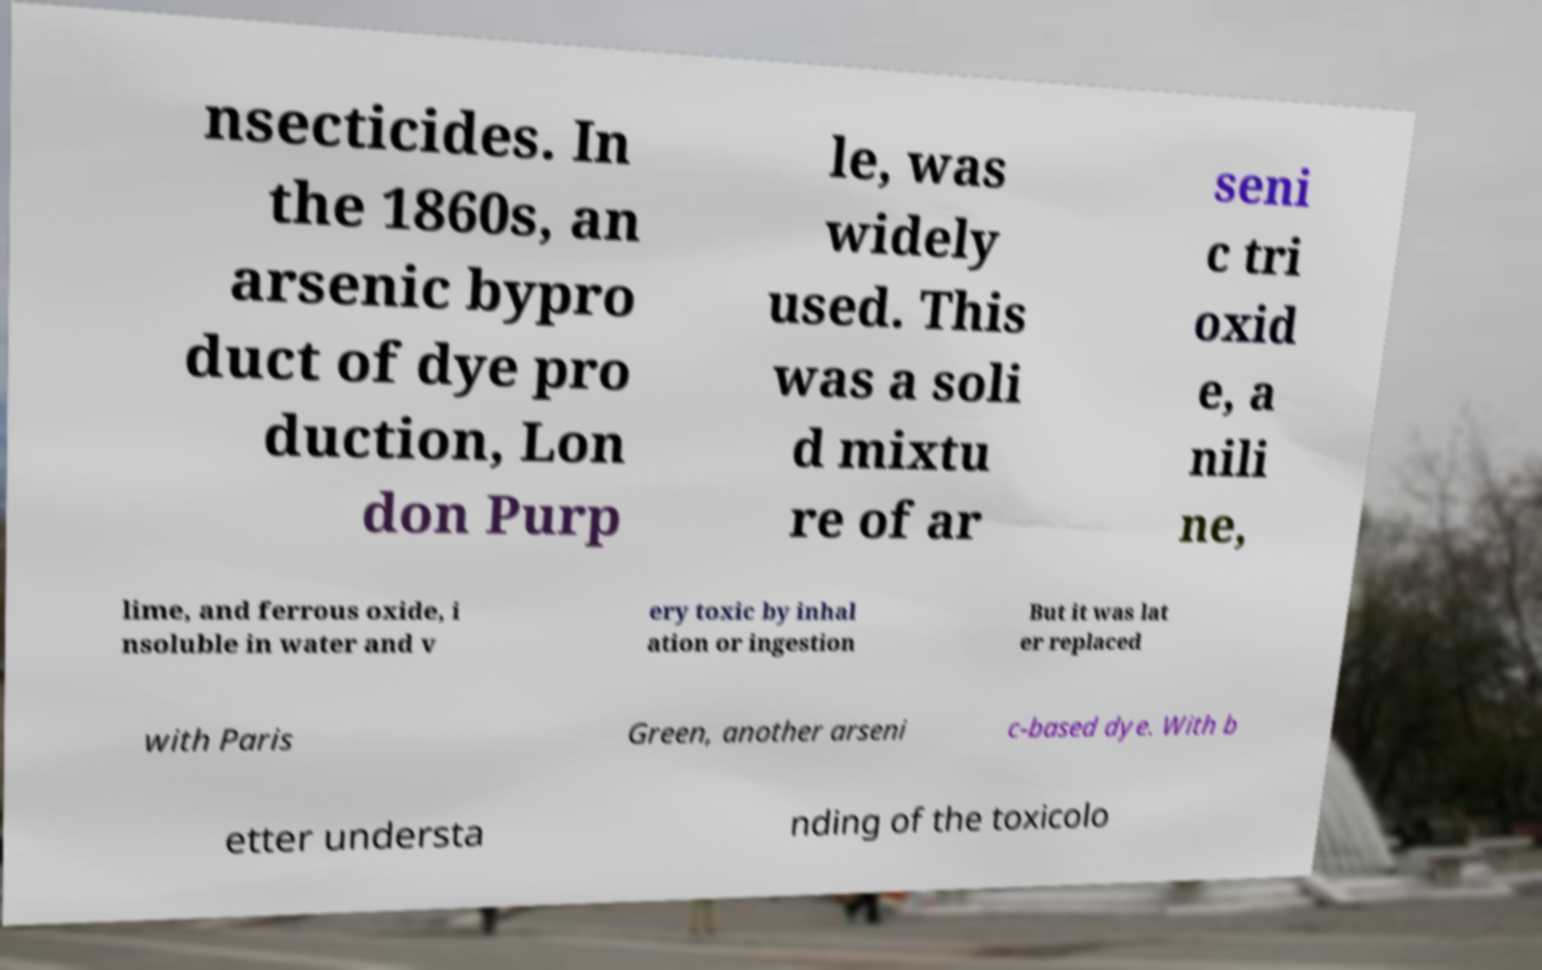For documentation purposes, I need the text within this image transcribed. Could you provide that? nsecticides. In the 1860s, an arsenic bypro duct of dye pro duction, Lon don Purp le, was widely used. This was a soli d mixtu re of ar seni c tri oxid e, a nili ne, lime, and ferrous oxide, i nsoluble in water and v ery toxic by inhal ation or ingestion But it was lat er replaced with Paris Green, another arseni c-based dye. With b etter understa nding of the toxicolo 